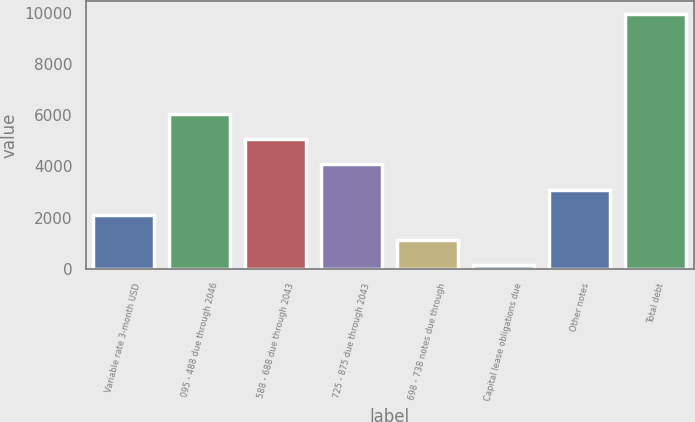Convert chart. <chart><loc_0><loc_0><loc_500><loc_500><bar_chart><fcel>Variable rate 3-month USD<fcel>095 - 488 due through 2046<fcel>588 - 688 due through 2043<fcel>725 - 875 due through 2043<fcel>698 - 738 notes due through<fcel>Capital lease obligations due<fcel>Other notes<fcel>Total debt<nl><fcel>2112.8<fcel>6038.4<fcel>5057<fcel>4075.6<fcel>1131.4<fcel>150<fcel>3094.2<fcel>9964<nl></chart> 